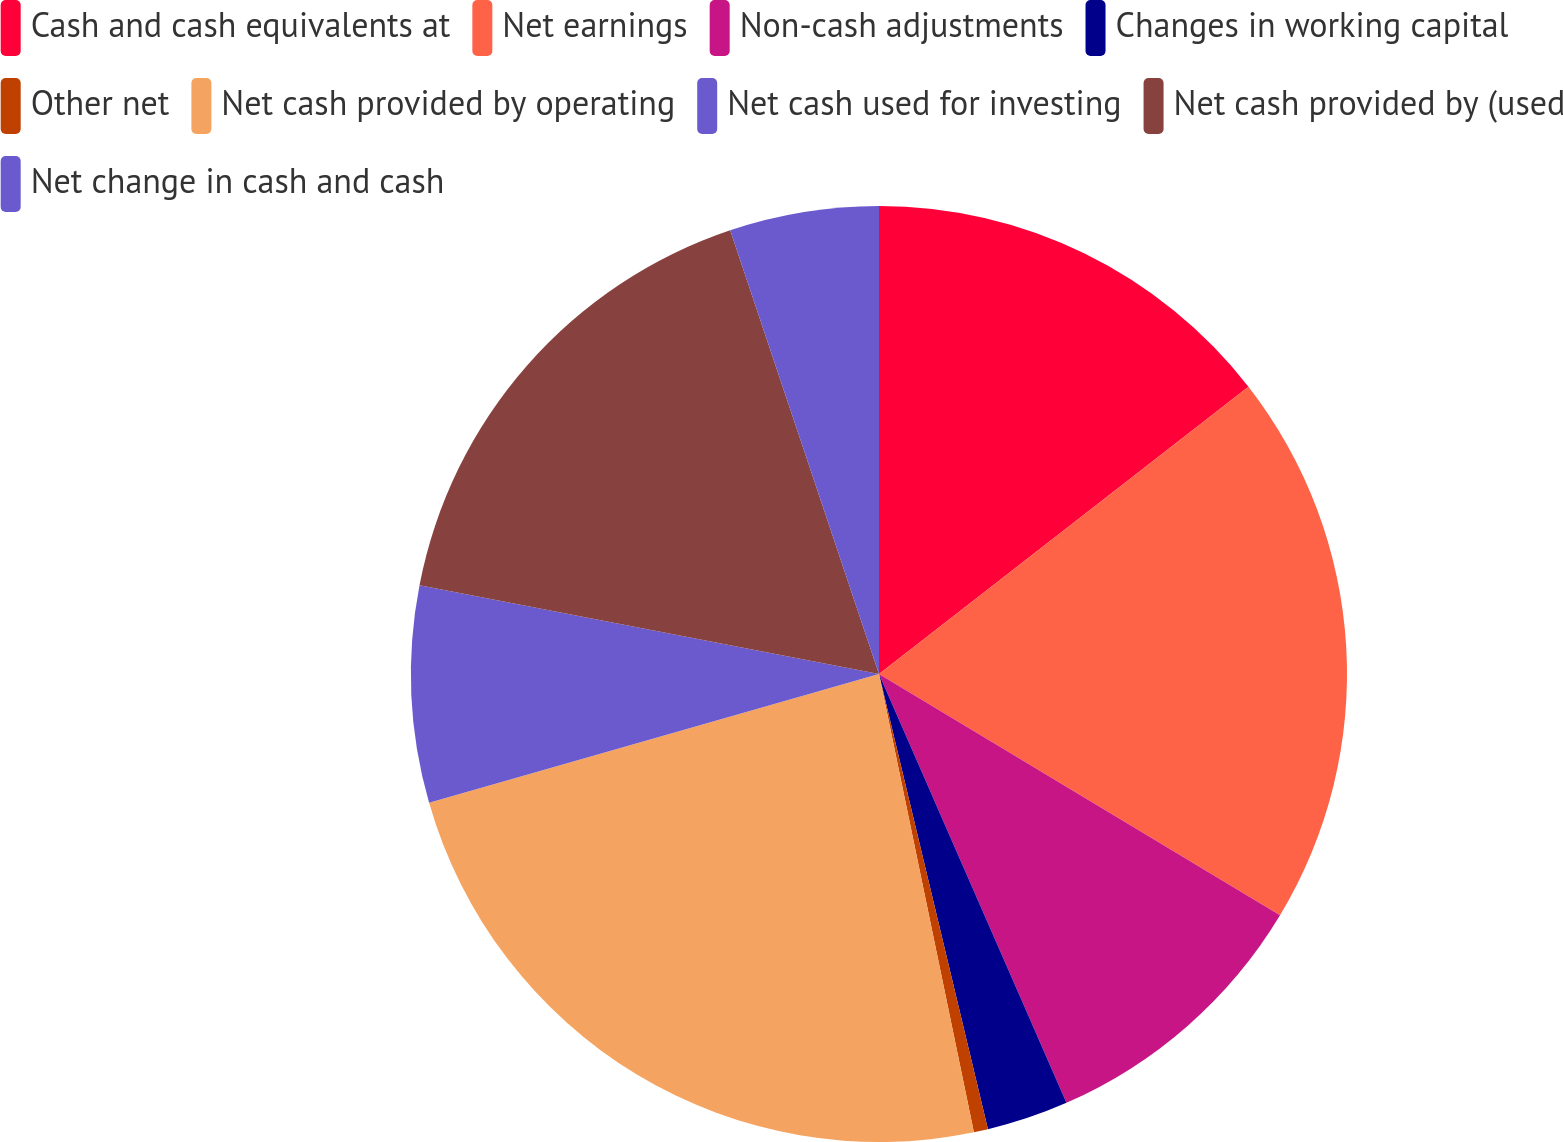Convert chart. <chart><loc_0><loc_0><loc_500><loc_500><pie_chart><fcel>Cash and cash equivalents at<fcel>Net earnings<fcel>Non-cash adjustments<fcel>Changes in working capital<fcel>Other net<fcel>Net cash provided by operating<fcel>Net cash used for investing<fcel>Net cash provided by (used<fcel>Net change in cash and cash<nl><fcel>14.48%<fcel>19.14%<fcel>9.82%<fcel>2.82%<fcel>0.49%<fcel>23.81%<fcel>7.48%<fcel>16.81%<fcel>5.15%<nl></chart> 